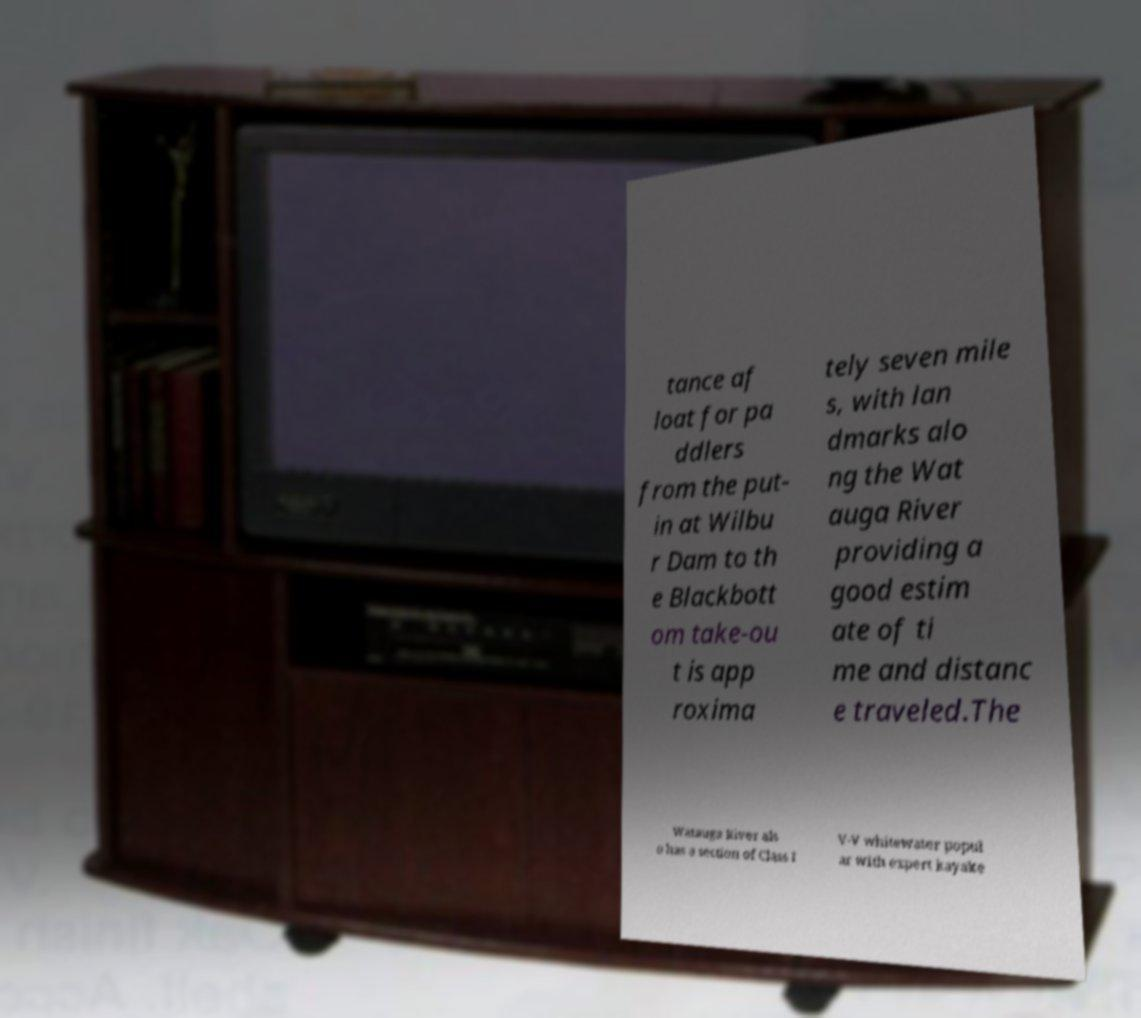Could you assist in decoding the text presented in this image and type it out clearly? tance af loat for pa ddlers from the put- in at Wilbu r Dam to th e Blackbott om take-ou t is app roxima tely seven mile s, with lan dmarks alo ng the Wat auga River providing a good estim ate of ti me and distanc e traveled.The Watauga River als o has a section of Class I V-V whitewater popul ar with expert kayake 